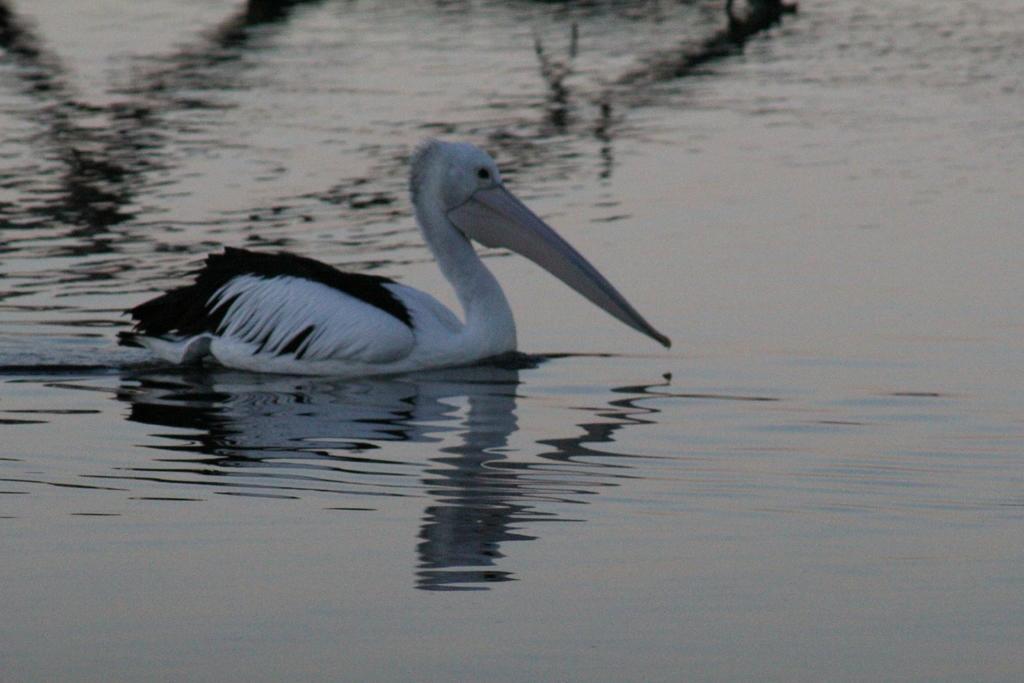In one or two sentences, can you explain what this image depicts? On the left side, there is a bird in white and black color combination. It is swimming in the water. 